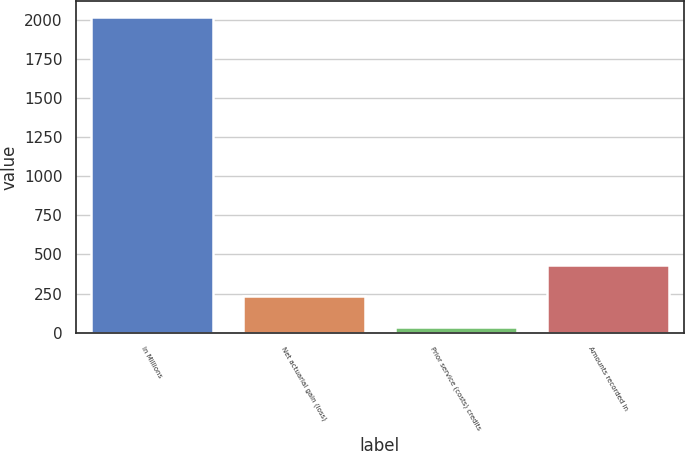<chart> <loc_0><loc_0><loc_500><loc_500><bar_chart><fcel>In Millions<fcel>Net actuarial gain (loss)<fcel>Prior service (costs) credits<fcel>Amounts recorded in<nl><fcel>2018<fcel>231.59<fcel>33.1<fcel>430.08<nl></chart> 